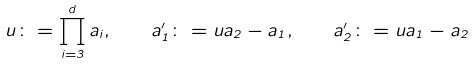Convert formula to latex. <formula><loc_0><loc_0><loc_500><loc_500>u \colon = \prod _ { i = 3 } ^ { d } a _ { i } , \quad a _ { 1 } ^ { \prime } \colon = u a _ { 2 } - a _ { 1 } , \quad a _ { 2 } ^ { \prime } \colon = u a _ { 1 } - a _ { 2 }</formula> 